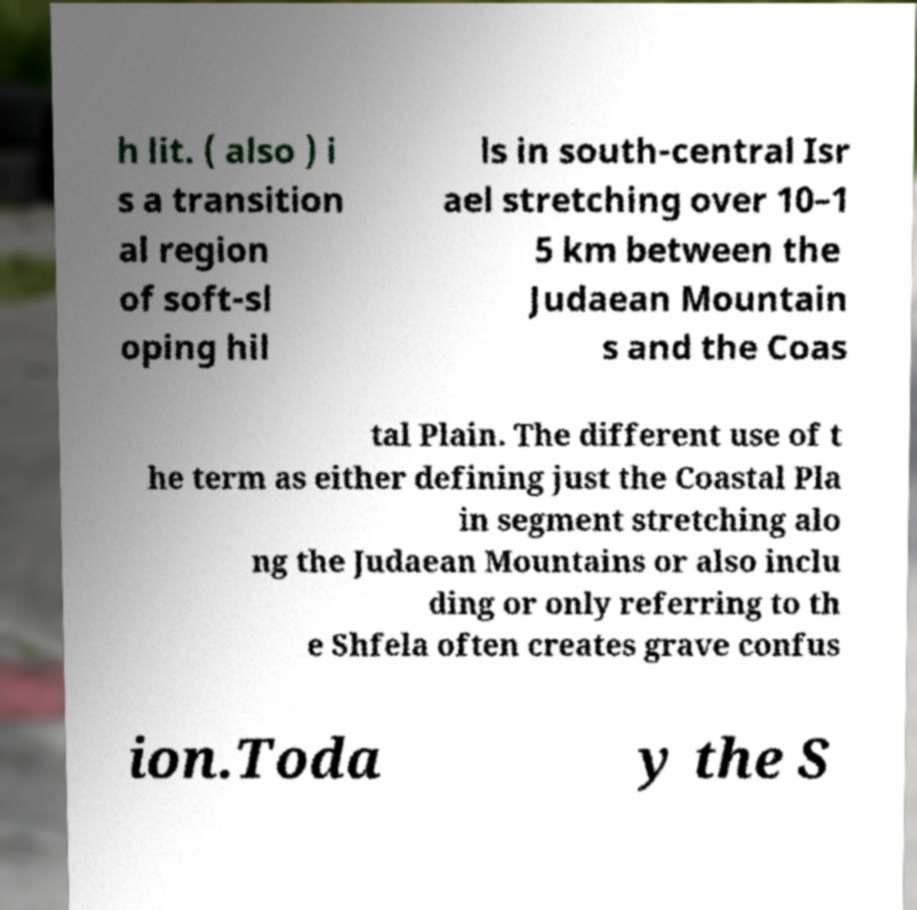For documentation purposes, I need the text within this image transcribed. Could you provide that? h lit. ( also ) i s a transition al region of soft-sl oping hil ls in south-central Isr ael stretching over 10–1 5 km between the Judaean Mountain s and the Coas tal Plain. The different use of t he term as either defining just the Coastal Pla in segment stretching alo ng the Judaean Mountains or also inclu ding or only referring to th e Shfela often creates grave confus ion.Toda y the S 